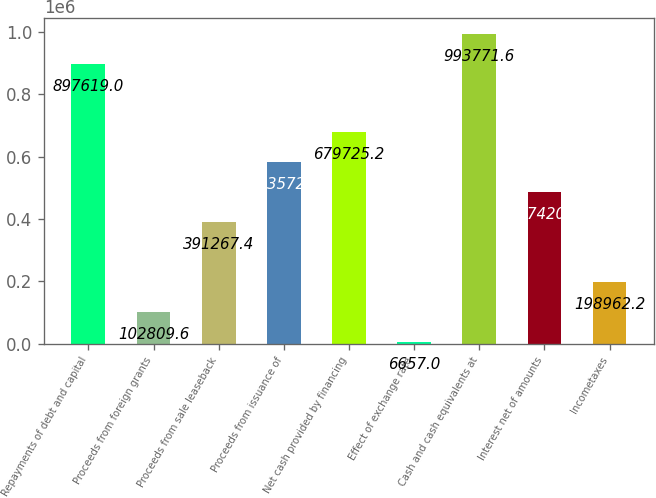<chart> <loc_0><loc_0><loc_500><loc_500><bar_chart><fcel>Repayments of debt and capital<fcel>Proceeds from foreign grants<fcel>Proceeds from sale leaseback<fcel>Proceeds from issuance of<fcel>Net cash provided by financing<fcel>Effect of exchange rate<fcel>Cash and cash equivalents at<fcel>Interest net of amounts<fcel>Incometaxes<nl><fcel>897619<fcel>102810<fcel>391267<fcel>583573<fcel>679725<fcel>6657<fcel>993772<fcel>487420<fcel>198962<nl></chart> 